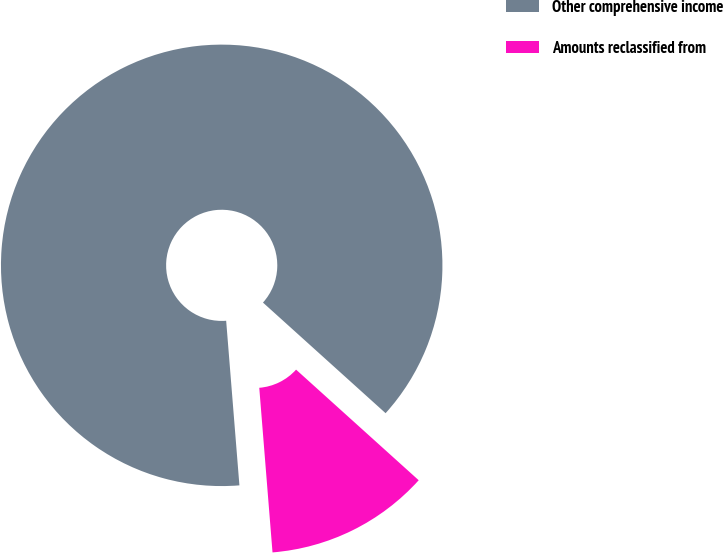Convert chart to OTSL. <chart><loc_0><loc_0><loc_500><loc_500><pie_chart><fcel>Other comprehensive income<fcel>Amounts reclassified from<nl><fcel>87.96%<fcel>12.04%<nl></chart> 